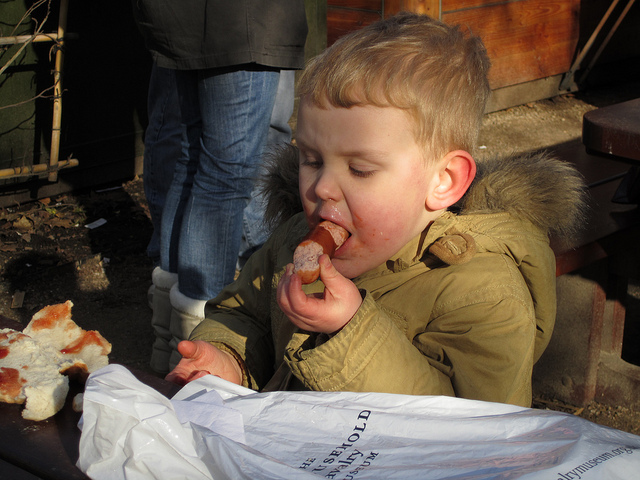Read and extract the text from this image. HE USENOLD avalry JSEUM lrymuseum.org 